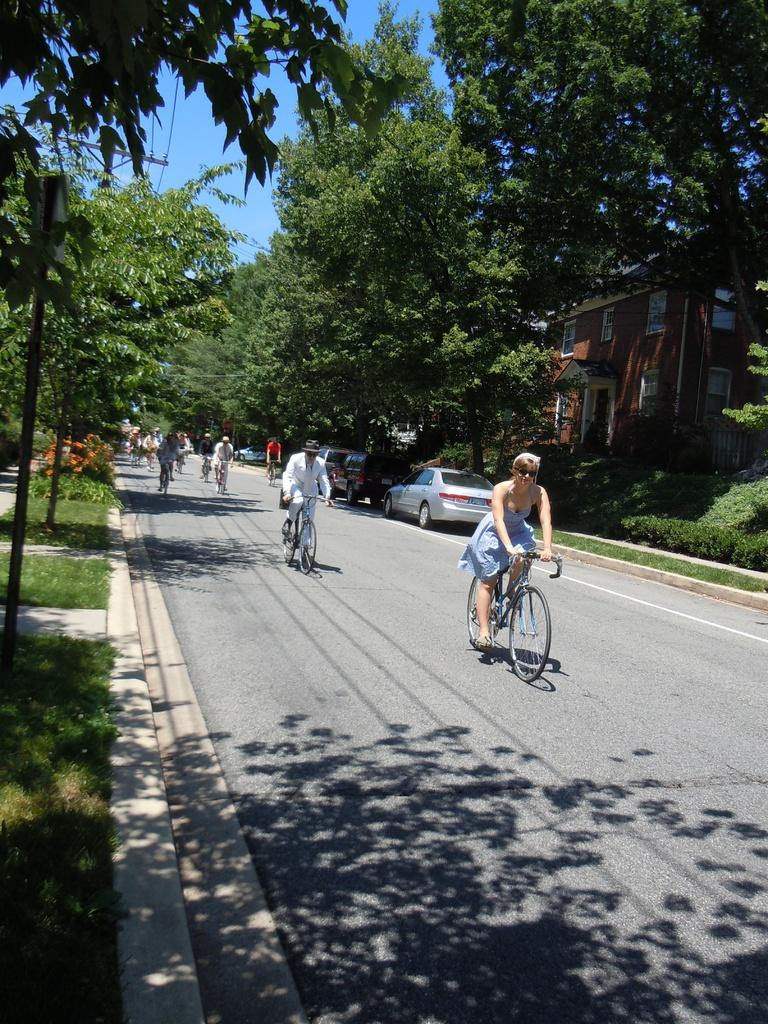What are the two people in the image doing? The two people in the image are riding bicycles. What can be seen in the background of the image? There are trees visible in the image. What type of structure is present in the image? There is a house in the image. What else can be seen on the road in the image? There are parked cars on the road in the image. Where is the oil pump located in the image? There is no oil pump present in the image. What type of trouble are the people on bicycles experiencing in the image? There is no indication of trouble in the image; the people are simply riding their bicycles. 